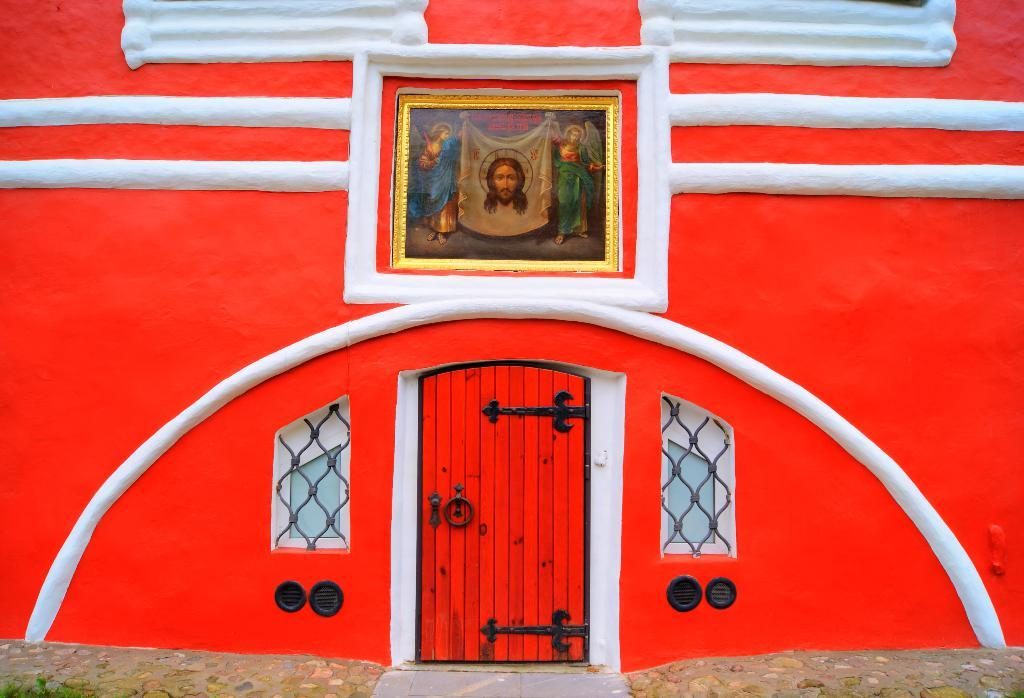What is the color scheme of the building in the image? The building in the image has a red and white color scheme. How is the frame positioned in the image? The frame is attached to the wall in the image. What is a common feature of buildings that can be seen in the image? There is a door in the image. Are there any openings in the building that allow light and air to enter? Yes, there are windows in the image. What type of insurance is being advertised on the building in the image? There is no indication of any insurance being advertised on the building in the image. How many basins are visible in the image? There are no basins present in the image. 